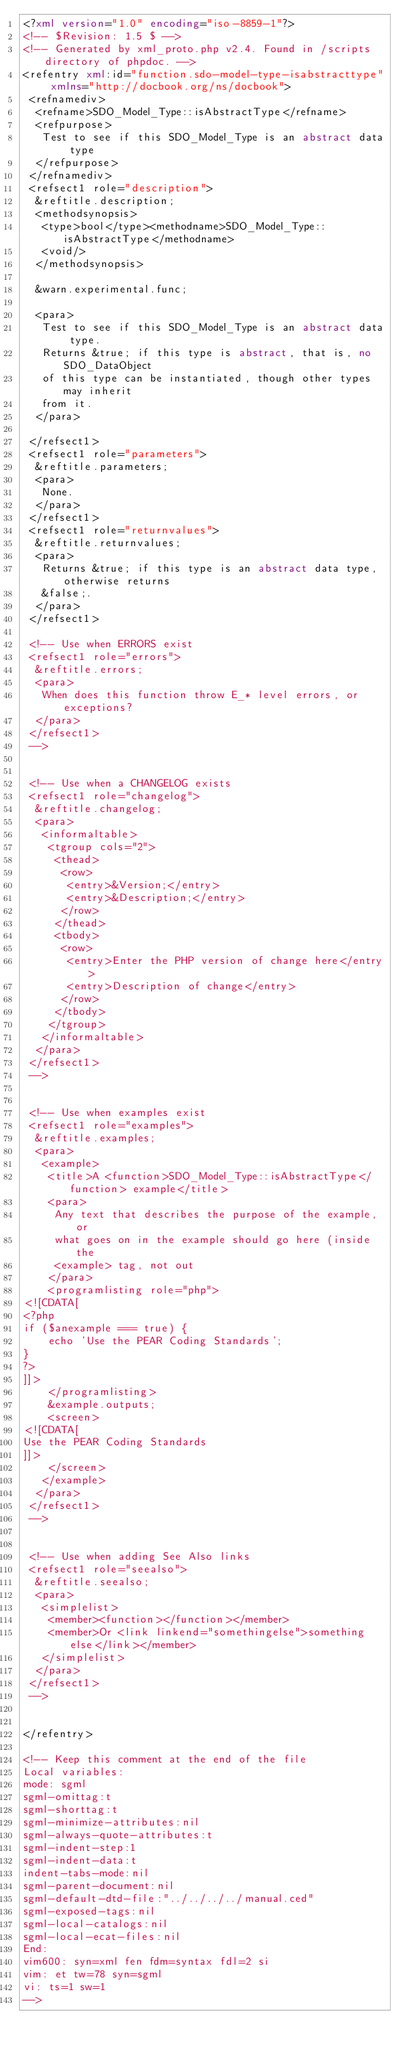Convert code to text. <code><loc_0><loc_0><loc_500><loc_500><_XML_><?xml version="1.0" encoding="iso-8859-1"?>
<!-- $Revision: 1.5 $ -->
<!-- Generated by xml_proto.php v2.4. Found in /scripts directory of phpdoc. -->
<refentry xml:id="function.sdo-model-type-isabstracttype" xmlns="http://docbook.org/ns/docbook">
 <refnamediv>
  <refname>SDO_Model_Type::isAbstractType</refname>
  <refpurpose>
   Test to see if this SDO_Model_Type is an abstract data type
  </refpurpose>
 </refnamediv>
 <refsect1 role="description">
  &reftitle.description;
  <methodsynopsis>
   <type>bool</type><methodname>SDO_Model_Type::isAbstractType</methodname>
   <void/>
  </methodsynopsis>

  &warn.experimental.func;

  <para>
   Test to see if this SDO_Model_Type is an abstract data type.
   Returns &true; if this type is abstract, that is, no SDO_DataObject
   of this type can be instantiated, though other types may inherit
   from it.
  </para>

 </refsect1>
 <refsect1 role="parameters">
  &reftitle.parameters;
  <para>
   None.
  </para>
 </refsect1>
 <refsect1 role="returnvalues">
  &reftitle.returnvalues;
  <para>
   Returns &true; if this type is an abstract data type, otherwise returns 
   &false;.
  </para>
 </refsect1>

 <!-- Use when ERRORS exist
 <refsect1 role="errors">
  &reftitle.errors;
  <para>
   When does this function throw E_* level errors, or exceptions?
  </para>
 </refsect1>
 -->


 <!-- Use when a CHANGELOG exists
 <refsect1 role="changelog">
  &reftitle.changelog;
  <para>
   <informaltable>
    <tgroup cols="2">
     <thead>
      <row>
       <entry>&Version;</entry>
       <entry>&Description;</entry>
      </row>
     </thead>
     <tbody>
      <row>
       <entry>Enter the PHP version of change here</entry>
       <entry>Description of change</entry>
      </row>
     </tbody>
    </tgroup>
   </informaltable>
  </para>
 </refsect1>
 -->


 <!-- Use when examples exist
 <refsect1 role="examples">
  &reftitle.examples;
  <para>
   <example>
    <title>A <function>SDO_Model_Type::isAbstractType</function> example</title>
    <para>
     Any text that describes the purpose of the example, or
     what goes on in the example should go here (inside the
     <example> tag, not out
    </para>
    <programlisting role="php">
<![CDATA[
<?php
if ($anexample === true) {
    echo 'Use the PEAR Coding Standards';
}
?>
]]>
    </programlisting>
    &example.outputs;
    <screen>
<![CDATA[
Use the PEAR Coding Standards
]]>
    </screen>
   </example>
  </para>
 </refsect1>
 -->


 <!-- Use when adding See Also links
 <refsect1 role="seealso">
  &reftitle.seealso;
  <para>
   <simplelist>
    <member><function></function></member>
    <member>Or <link linkend="somethingelse">something else</link></member>
   </simplelist>
  </para>
 </refsect1>
 -->


</refentry>

<!-- Keep this comment at the end of the file
Local variables:
mode: sgml
sgml-omittag:t
sgml-shorttag:t
sgml-minimize-attributes:nil
sgml-always-quote-attributes:t
sgml-indent-step:1
sgml-indent-data:t
indent-tabs-mode:nil
sgml-parent-document:nil
sgml-default-dtd-file:"../../../../manual.ced"
sgml-exposed-tags:nil
sgml-local-catalogs:nil
sgml-local-ecat-files:nil
End:
vim600: syn=xml fen fdm=syntax fdl=2 si
vim: et tw=78 syn=sgml
vi: ts=1 sw=1
-->
</code> 